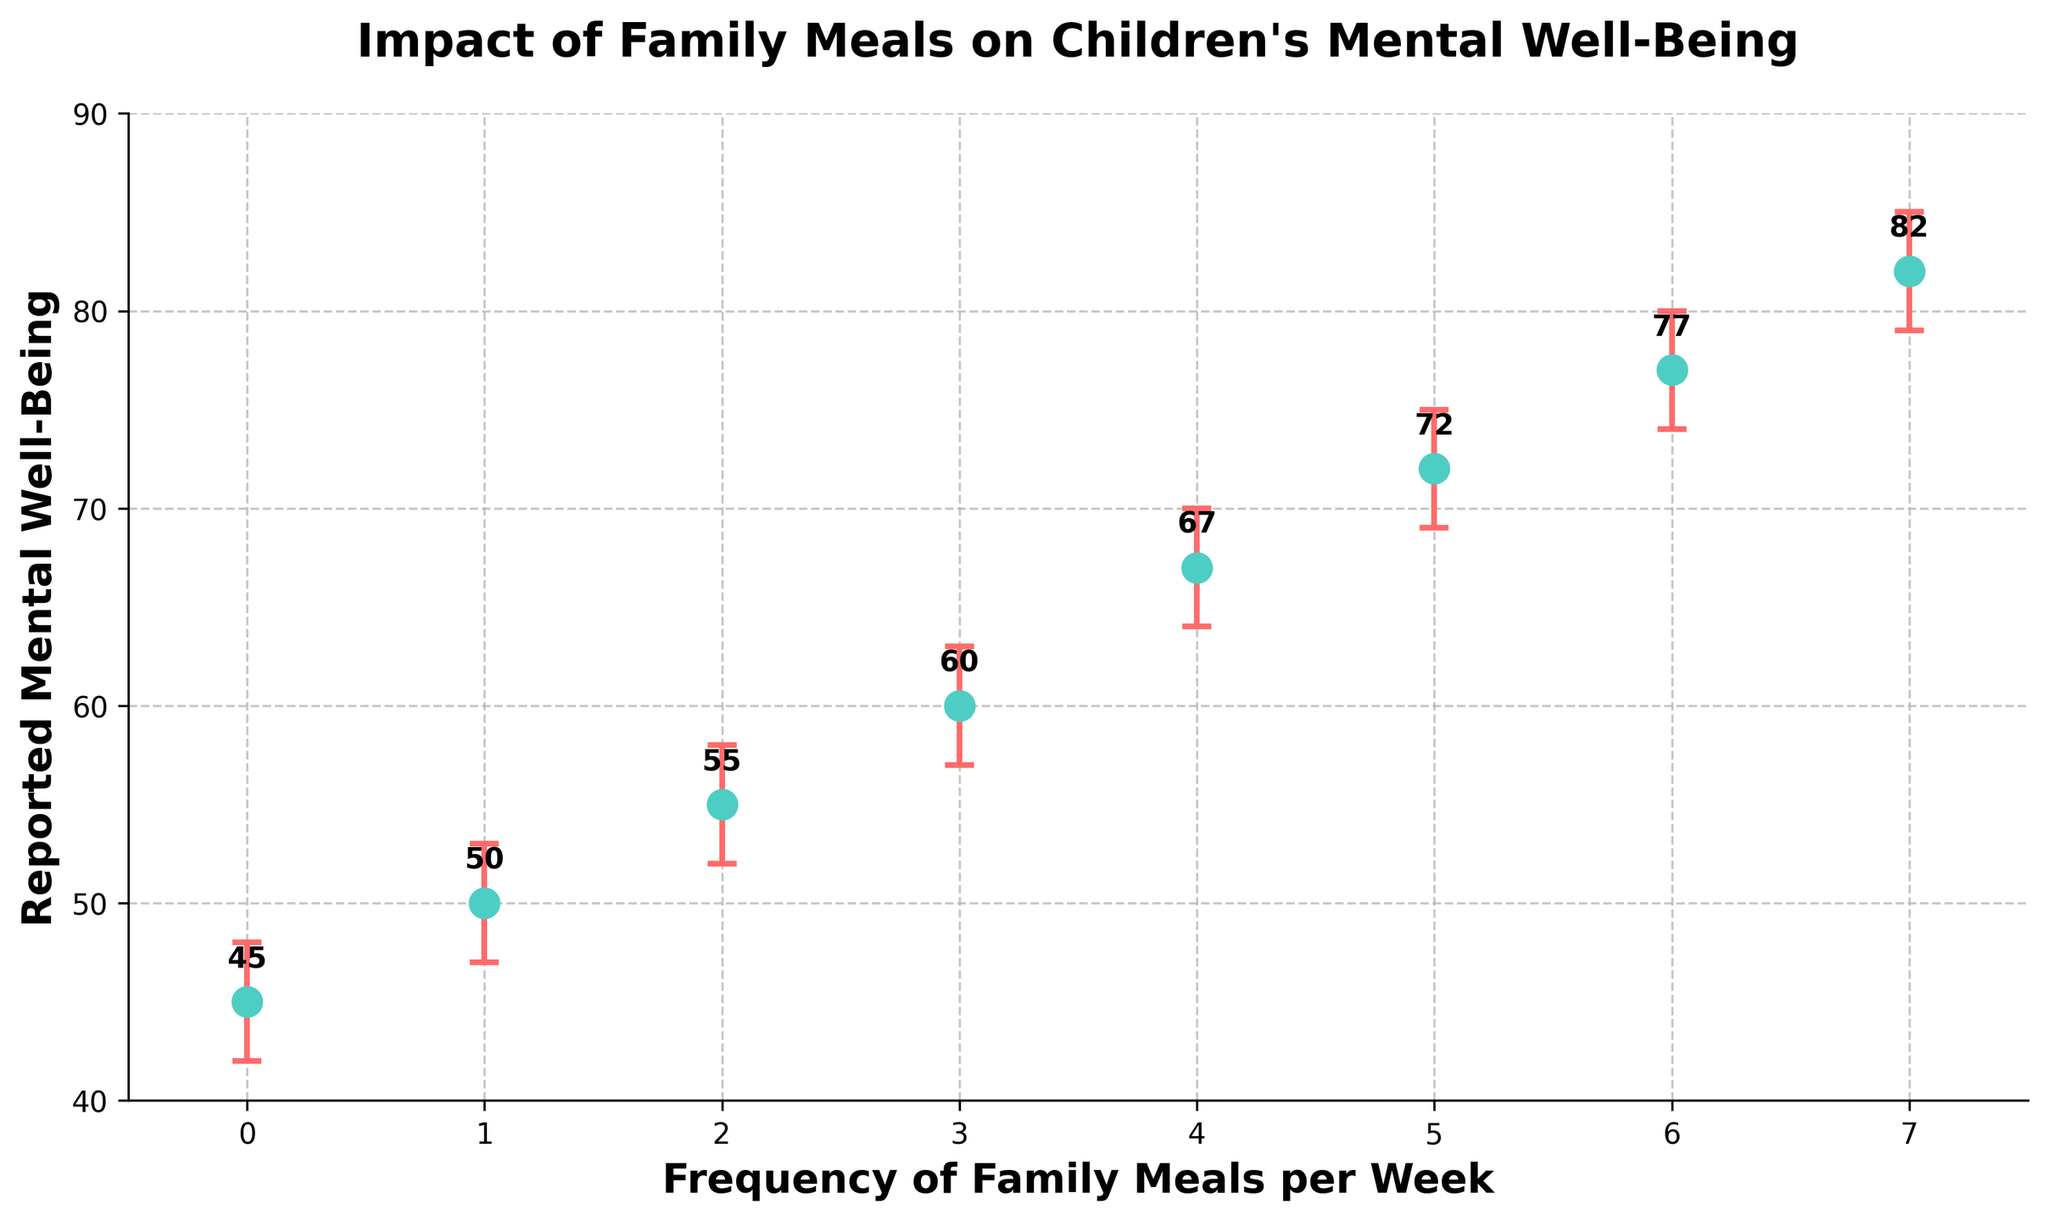What's the title of the figure? Look at the top center of the figure to find the title. It is positioned above the plot.
Answer: Impact of Family Meals on Children's Mental Well-Being What are the x-axis and y-axis labeled? The labels are positioned along the x-axis and y-axis of the plot. The x-axis is labeled "Frequency of Family Meals per Week" and the y-axis is labeled "Reported Mental Well-Being".
Answer: Frequency of Family Meals per Week, Reported Mental Well-Being How many data points are there in the plot? Count the number of markers (dots) representing data points in the plot. Each frequency of family meals corresponds to one data point.
Answer: 8 What is the reported mental well-being when the frequency of family meals is 4 per week? Find the data point corresponding to "4" on the x-axis and read the value on the y-axis directly above it.
Answer: 67 How do the confidence intervals change as the frequency of family meals increases? Observe and summarize how the length of the error bars changes along the x-axis. As the frequency increases, the confidence intervals tend to widen. This can be concluded by comparing the range from the lowest to the highest frequency on the plot.
Answer: They widen What is the difference in reported mental well-being between children who have family meals 7 times a week and 0 times a week? Identify the y-values corresponding to "7" and "0" on the x-axis, then calculate the difference. 82 (for 7 times a week) - 45 (for 0 times a week) = 37
Answer: 37 Which frequency of family meals has the highest reported mental well-being? Look for the data point with the highest value on the y-axis and note its corresponding x-axis value.
Answer: 7 At what frequency of family meals does the reported mental well-being first exceed 60? Find the lowest x-axis value where the y-axis value is greater than 60. "3" corresponds to 60, which is the first instance.
Answer: 4 What is the average reported mental well-being for frequencies of 5 and 6 family meals per week? Identify the y-values for frequencies of 5 and 6 family meals, sum them up, and then divide by 2. (72 + 77) / 2 = 74.5
Answer: 74.5 What is the difference between the upper and lower confidence intervals for 3 family meals per week? Determine the upper and lower confidence intervals for frequency 3, then calculate the difference: 63 - 57 = 6.
Answer: 6 